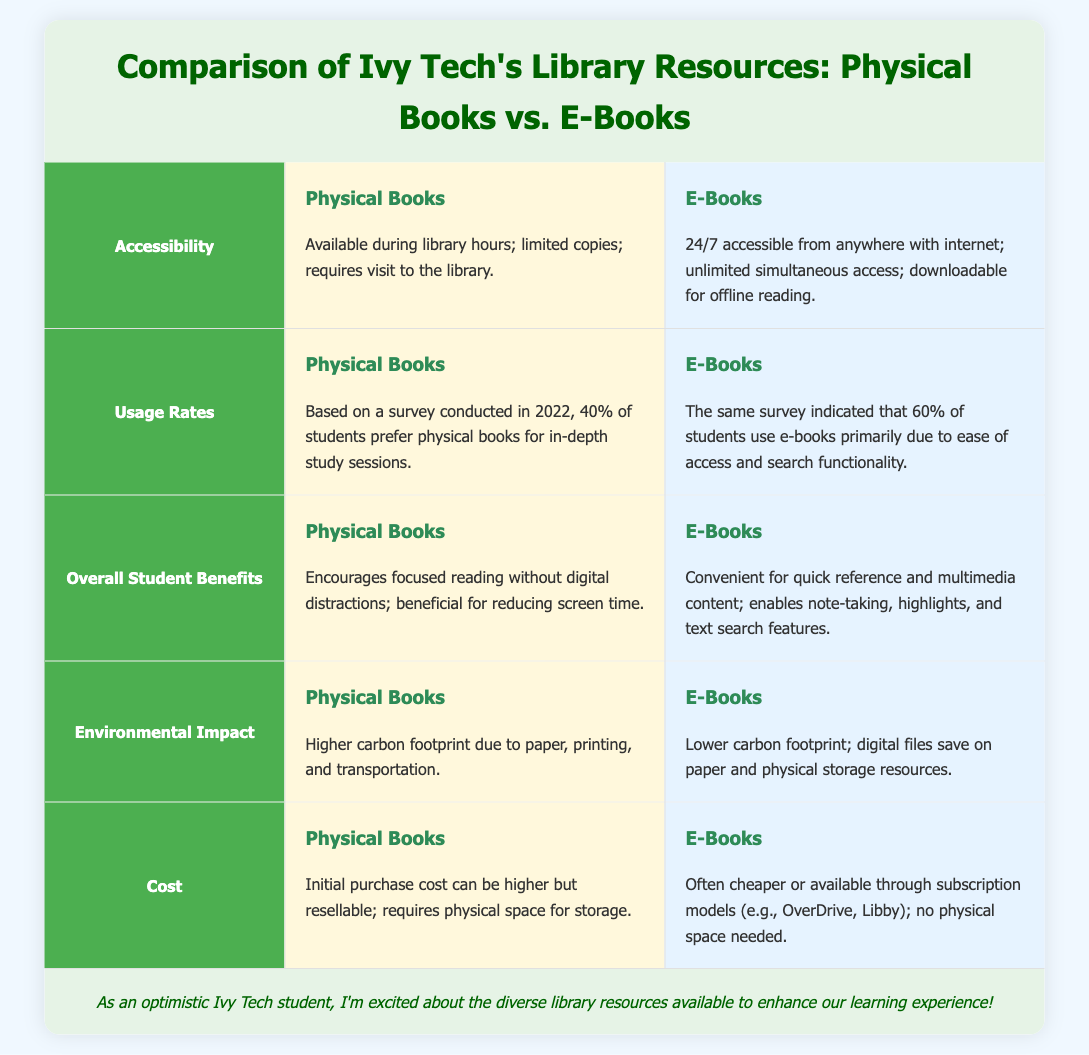What is the primary accessibility feature of E-Books? The document states that E-Books are accessible 24/7 from anywhere with internet.
Answer: 24/7 accessible from anywhere with internet What percentage of students prefer Physical Books according to the survey? The document mentions that 40% of students prefer Physical Books for in-depth study sessions, based on the survey.
Answer: 40% What are the benefits of Physical Books highlighted in the document? The document indicates that Physical Books encourage focused reading without digital distractions and reduce screen time.
Answer: Focused reading without digital distractions What is the carbon footprint of Physical Books described in the document? The document states that Physical Books have a higher carbon footprint due to paper, printing, and transportation.
Answer: Higher carbon footprint What is a noted feature of E-Books that enhances usability? The document highlights that E-Books enable note-taking, highlights, and text search features.
Answer: Note-taking, highlights, and text search features What type of access do Physical Books have during library hours? The document notes that Physical Books are available during library hours and require a visit to the library.
Answer: Available during library hours What percentage of students primarily use E-Books according to the survey? The document indicates that 60% of students use E-Books primarily due to ease of access.
Answer: 60% What is the initial purchase cost implication of Physical Books mentioned? The document states that the initial purchase cost of Physical Books can be higher but they are resellable.
Answer: Higher but resellable What environmental impact is associated with E-Books? The document mentions that E-Books have a lower carbon footprint, saving on paper and physical resources.
Answer: Lower carbon footprint 